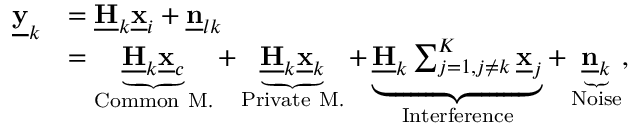<formula> <loc_0><loc_0><loc_500><loc_500>\begin{array} { r l } { \underline { y } _ { k } } & { = \underline { H } _ { k } \underline { x } _ { i } + \underline { n } _ { l k } } \\ & { = \underbrace { \underline { H } _ { k } \underline { x } _ { c } } _ { C o m m o n M . } + \underbrace { \underline { H } _ { k } \underline { x } _ { k } } _ { P r i v a t e M . } + \underbrace { \underline { H } _ { k } \sum _ { j = 1 , j \neq k } ^ { K } \underline { x } _ { j } } _ { I n t e r f e r e n c e } + \underbrace { \underline { n } _ { k } } _ { N o i s e } , } \end{array}</formula> 